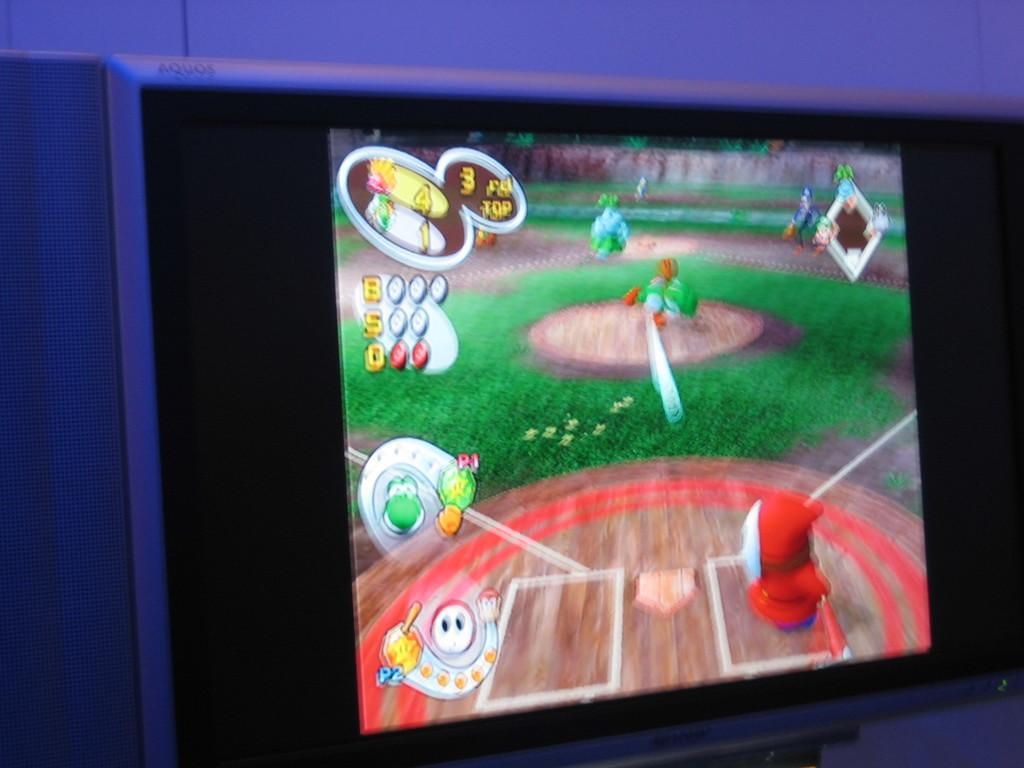Provide a one-sentence caption for the provided image. A screen showing a video game that includes Yoshi playing a sport. 